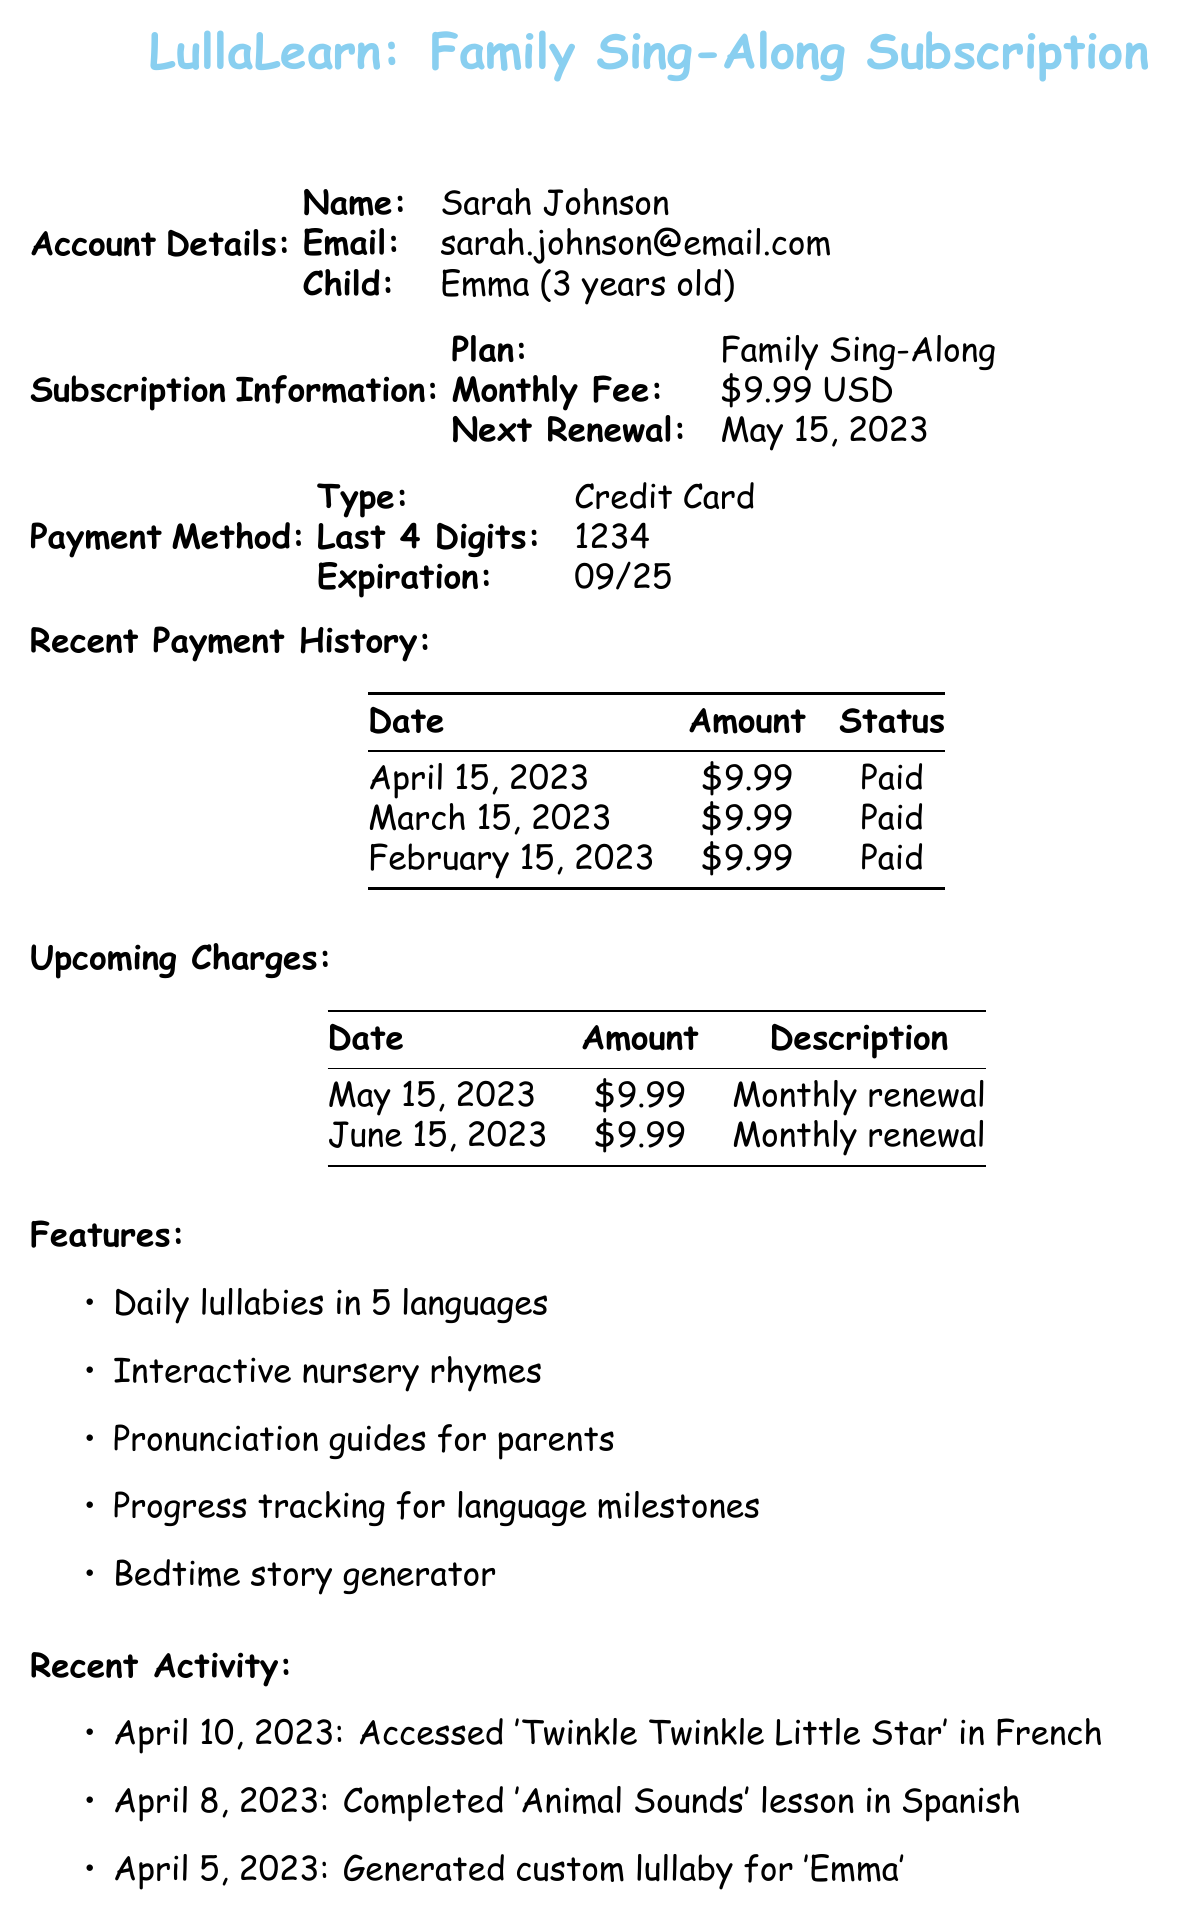What is the app name? The app name is stated at the beginning of the document as "LullaLearn."
Answer: LullaLearn What is the next renewal date? The document specifies the next renewal date in the subscription information section as "May 15, 2023."
Answer: May 15, 2023 How much is the monthly fee? The monthly fee is listed in the subscription information section as "$9.99 USD."
Answer: $9.99 What is the last payment date? The most recent payment date can be found in the payment history, which shows "April 15, 2023."
Answer: April 15, 2023 What features are provided by the app? The document lists various features including "Daily lullabies in 5 languages" among others in the features section.
Answer: Daily lullabies in 5 languages How many payments have been made in the history? The payment history section shows three entries for payments made, indicating the number of payments.
Answer: 3 What is the cancellation notice period? The cancellation policy specifies that the notice period is "7 days."
Answer: 7 days What is the refund eligibility policy? The refund eligibility clause states "Pro-rata refund for unused days."
Answer: Pro-rata refund for unused days What method is used for payment? The payment method section identifies the method as "Credit Card."
Answer: Credit Card 